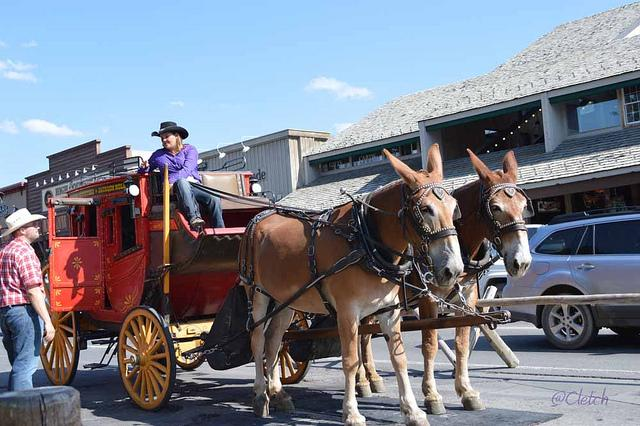What do both of the people have on their heads? Please explain your reasoning. cowboy hats. The two men that are visible are wearing cowboy-style hats on their heads and that is the only type of headwear seen. 